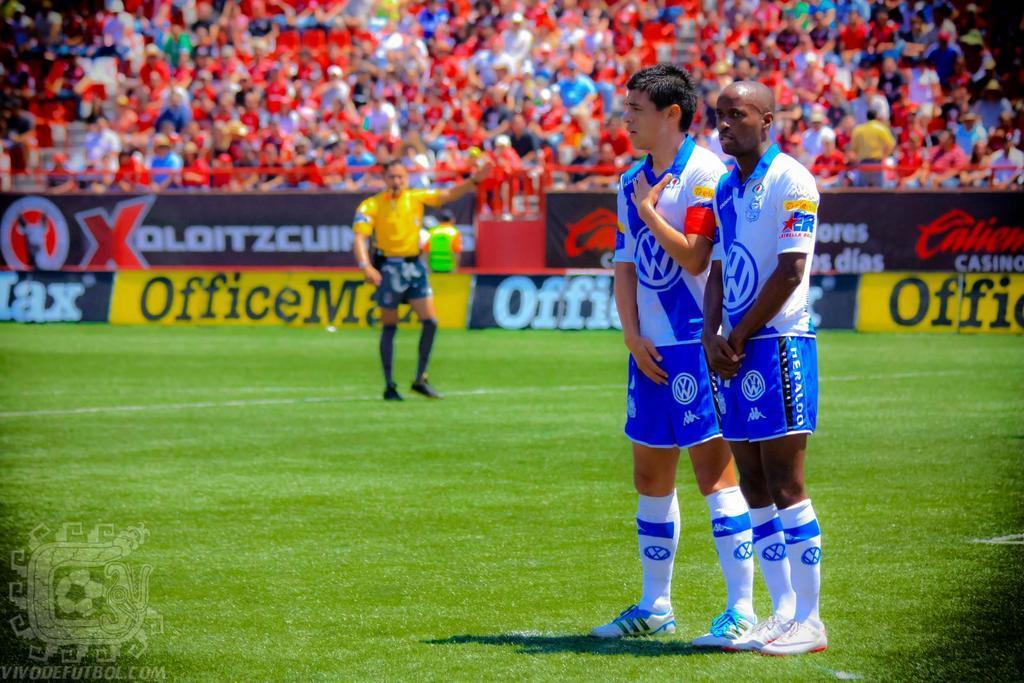In one or two sentences, can you explain what this image depicts? There are three persons on the ground and this is grass. There are hoardings. In the background we can see crowd. 